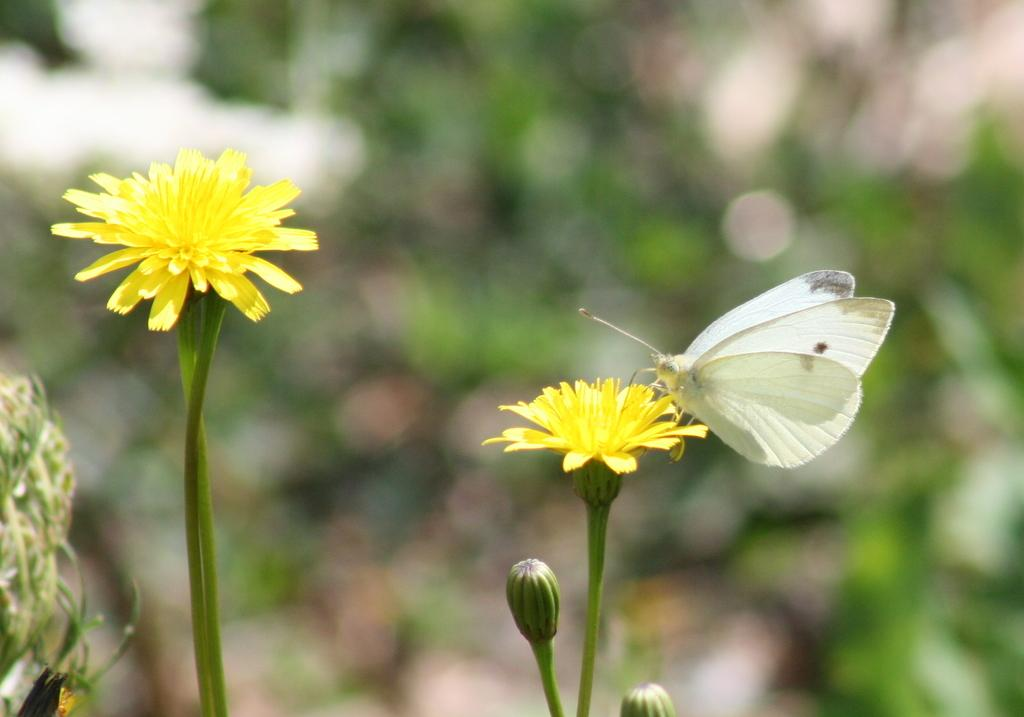How many yellow flowers are present in the image? There are 2 yellow color flowers in the image. What is the current stage of the buds in the image? There are 2 buds in the image. Is there any animal visible in the image? Yes, there is a white color butterfly on one of the flowers. Can you describe the background of the image? The background of the image is blurred. What type of eggnog is being served on the sidewalk in the image? There is no eggnog or sidewalk present in the image; it features flowers and a butterfly. How many wings does the butterfly have in the image? The butterfly in the image has two wings, as is typical for butterflies. 